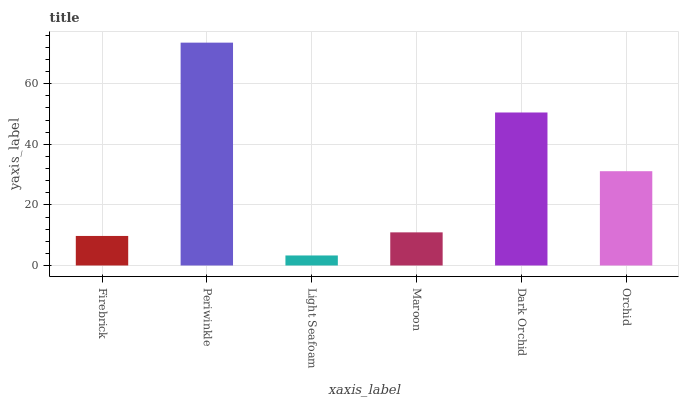Is Light Seafoam the minimum?
Answer yes or no. Yes. Is Periwinkle the maximum?
Answer yes or no. Yes. Is Periwinkle the minimum?
Answer yes or no. No. Is Light Seafoam the maximum?
Answer yes or no. No. Is Periwinkle greater than Light Seafoam?
Answer yes or no. Yes. Is Light Seafoam less than Periwinkle?
Answer yes or no. Yes. Is Light Seafoam greater than Periwinkle?
Answer yes or no. No. Is Periwinkle less than Light Seafoam?
Answer yes or no. No. Is Orchid the high median?
Answer yes or no. Yes. Is Maroon the low median?
Answer yes or no. Yes. Is Periwinkle the high median?
Answer yes or no. No. Is Periwinkle the low median?
Answer yes or no. No. 